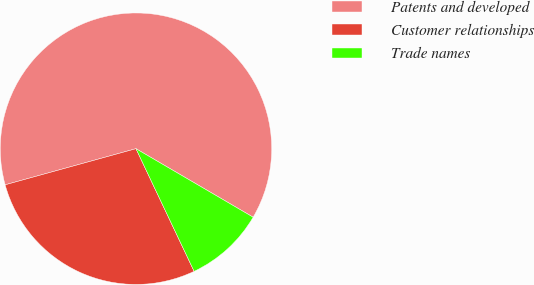<chart> <loc_0><loc_0><loc_500><loc_500><pie_chart><fcel>Patents and developed<fcel>Customer relationships<fcel>Trade names<nl><fcel>62.71%<fcel>27.76%<fcel>9.53%<nl></chart> 